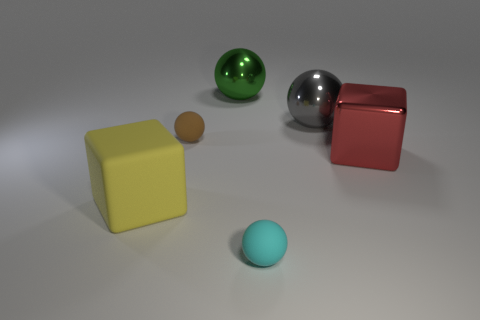Subtract all small brown matte spheres. How many spheres are left? 3 Add 1 blue rubber cylinders. How many objects exist? 7 Subtract all red blocks. How many blocks are left? 1 Subtract all cubes. How many objects are left? 4 Subtract 1 blocks. How many blocks are left? 1 Add 5 blue cubes. How many blue cubes exist? 5 Subtract 0 green cubes. How many objects are left? 6 Subtract all cyan balls. Subtract all purple cubes. How many balls are left? 3 Subtract all big red objects. Subtract all cyan matte spheres. How many objects are left? 4 Add 6 metallic balls. How many metallic balls are left? 8 